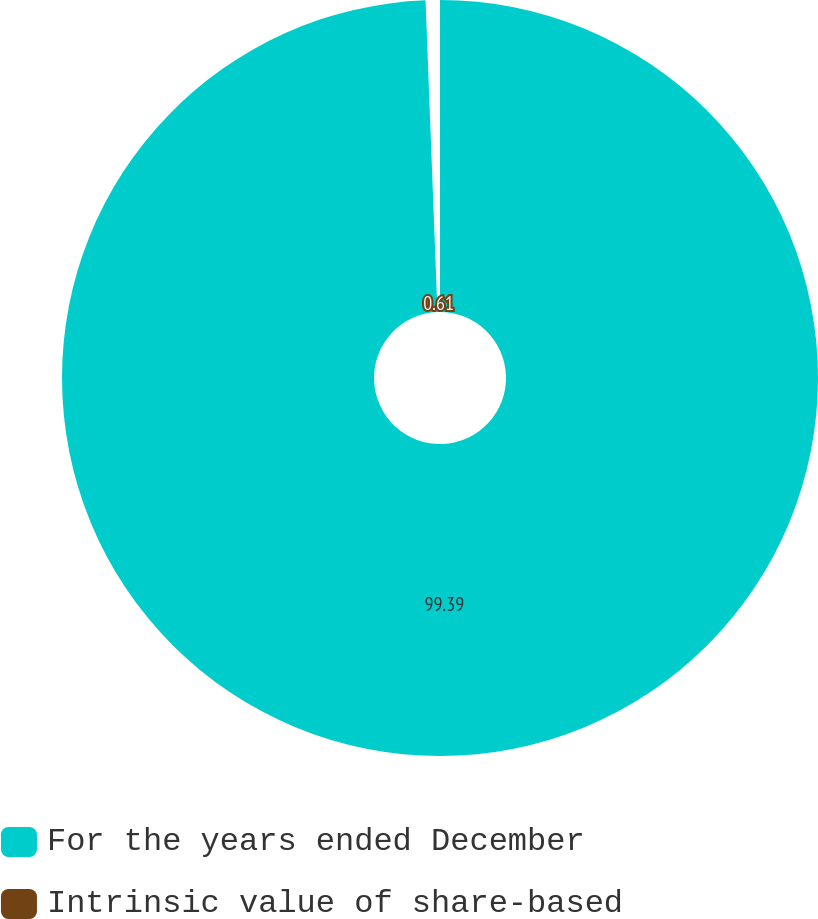<chart> <loc_0><loc_0><loc_500><loc_500><pie_chart><fcel>For the years ended December<fcel>Intrinsic value of share-based<nl><fcel>99.39%<fcel>0.61%<nl></chart> 